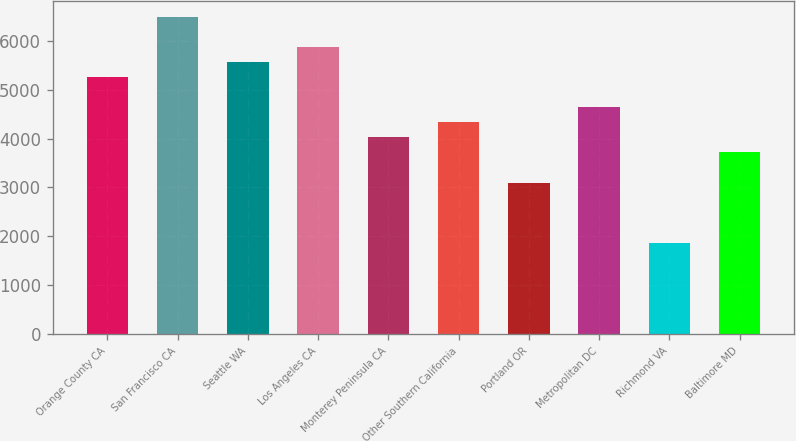Convert chart to OTSL. <chart><loc_0><loc_0><loc_500><loc_500><bar_chart><fcel>Orange County CA<fcel>San Francisco CA<fcel>Seattle WA<fcel>Los Angeles CA<fcel>Monterey Peninsula CA<fcel>Other Southern California<fcel>Portland OR<fcel>Metropolitan DC<fcel>Richmond VA<fcel>Baltimore MD<nl><fcel>5259.6<fcel>6492.4<fcel>5567.8<fcel>5876<fcel>4026.8<fcel>4335<fcel>3102.2<fcel>4643.2<fcel>1869.4<fcel>3718.6<nl></chart> 